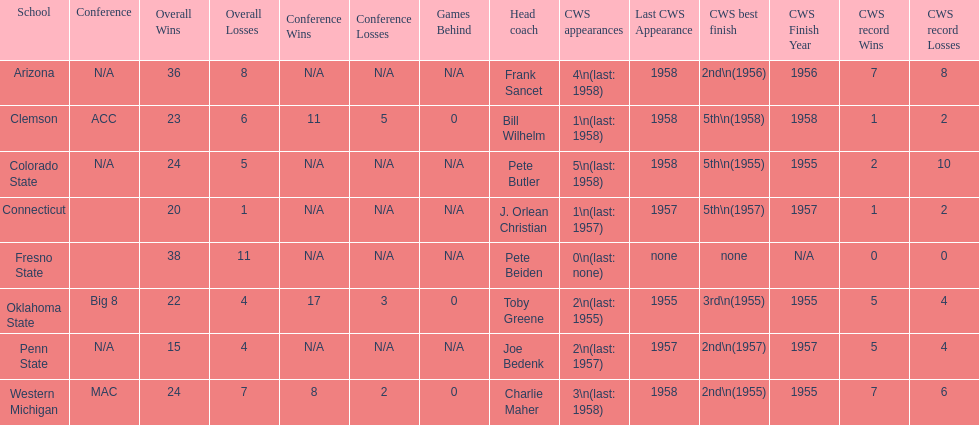Which was the only team with less than 20 wins? Penn State. 